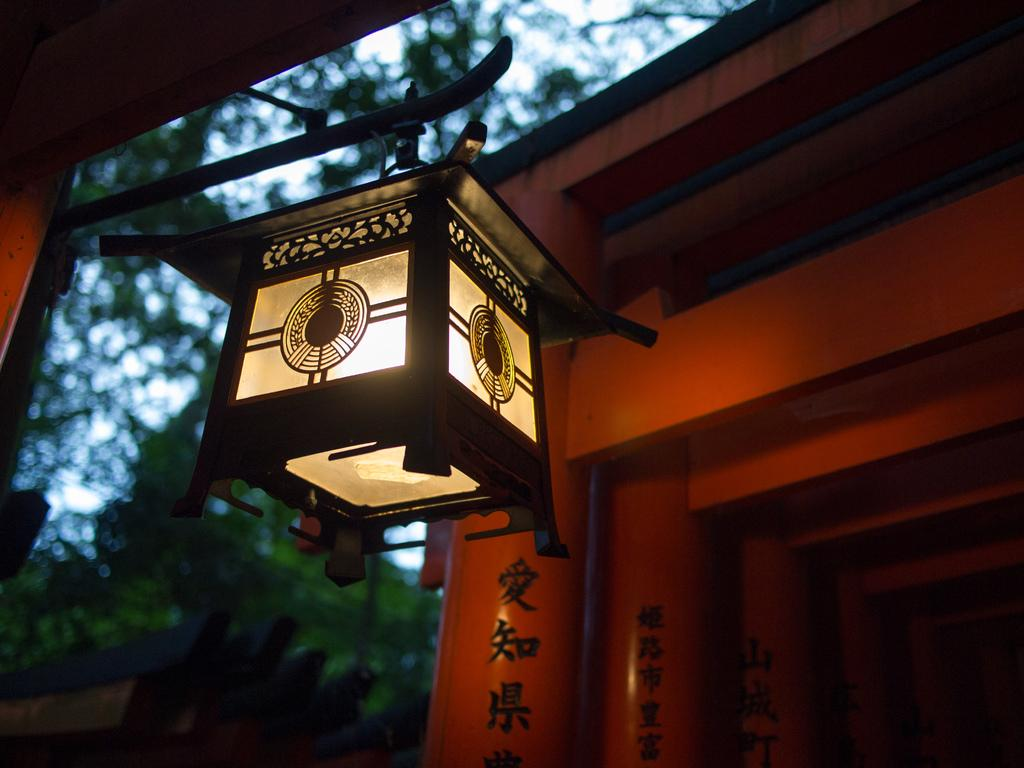What can be seen in the image? Light is visible in the image. What type of natural elements can be seen in the background of the image? There are trees and the sky visible in the background of the image. What architectural features are present in the background of the image? There are pillars in the background of the image. What type of steam is coming out of the trees in the image? There is no steam present in the image; it features light, trees, pillars, and the sky. How does the sleet affect the visibility of the pillars in the image? There is no sleet present in the image, so it does not affect the visibility of the pillars. 